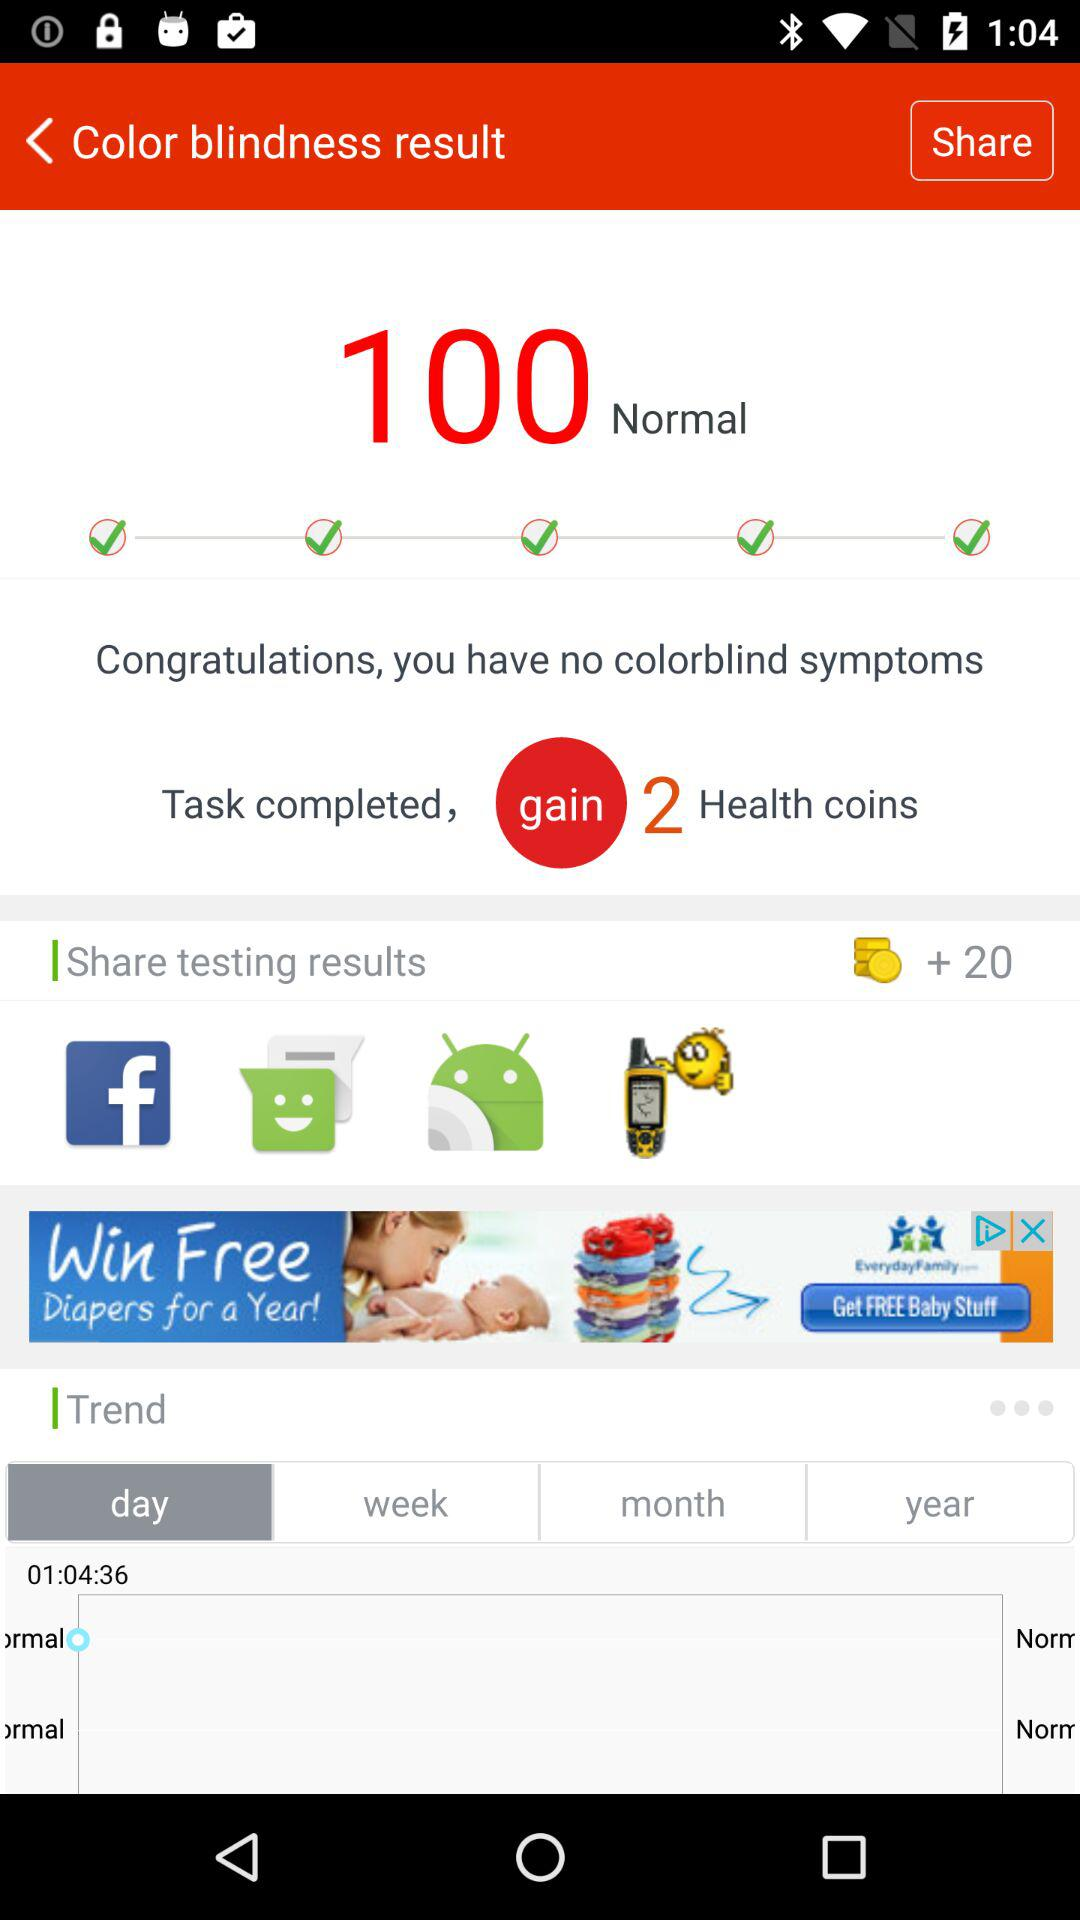After completing the task, how many Health coins will be gained? After completing the task, 2 health coins will be gained. 